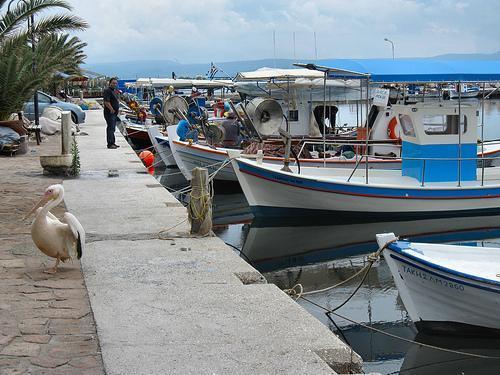How many boats are in the photo?
Give a very brief answer. 7. 